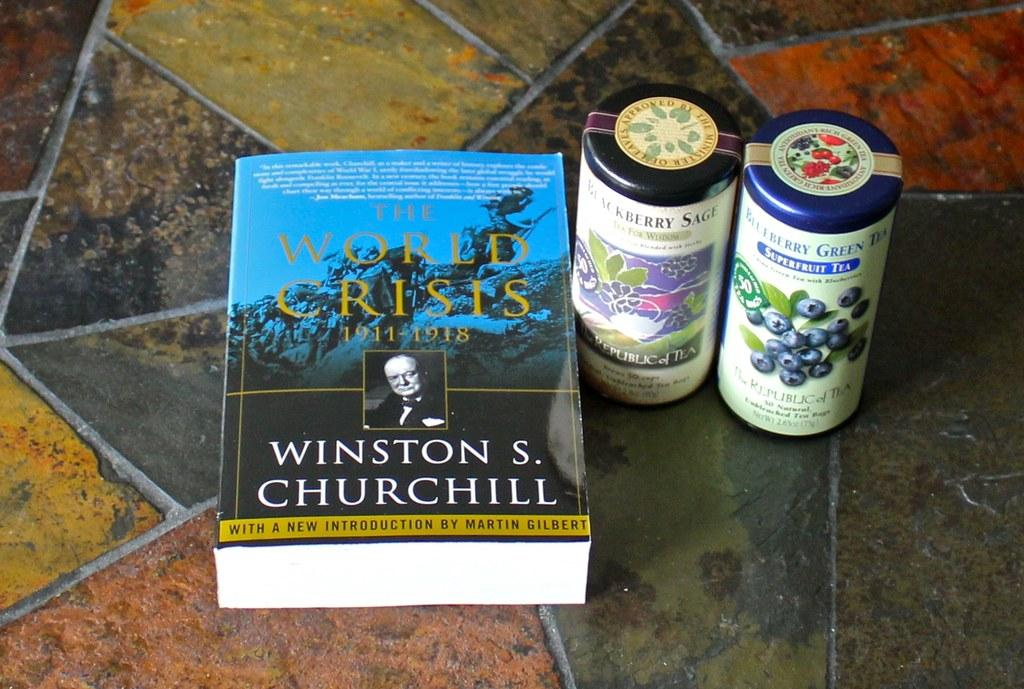<image>
Present a compact description of the photo's key features. A book by Churchill sits next to two canisters of tea. 